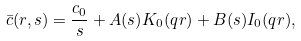<formula> <loc_0><loc_0><loc_500><loc_500>\bar { c } ( r , s ) = \frac { c _ { 0 } } { s } + A ( s ) K _ { 0 } ( q r ) + B ( s ) I _ { 0 } ( q r ) ,</formula> 